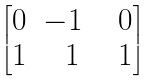<formula> <loc_0><loc_0><loc_500><loc_500>\begin{bmatrix} 0 & - 1 & \ \ 0 \\ 1 & \ \ 1 & \ \ 1 \end{bmatrix}</formula> 